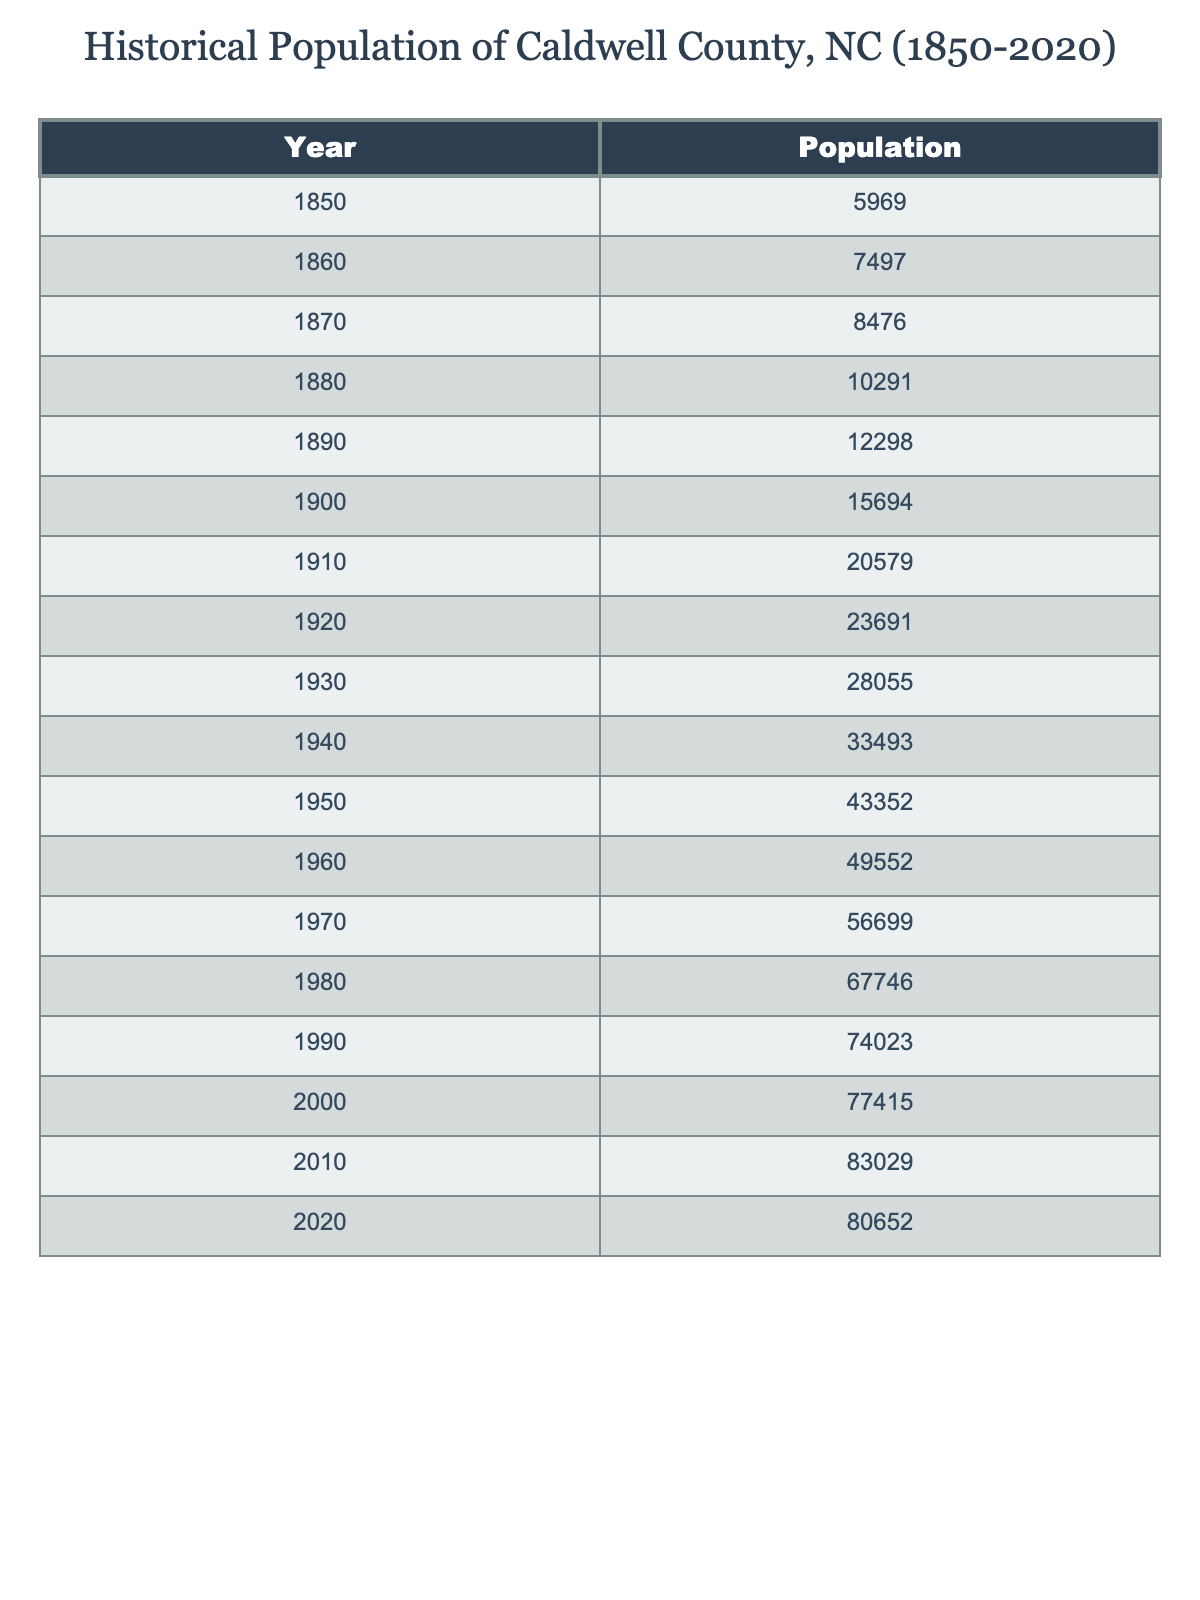What was the population of Caldwell County in 1850? According to the table, the population listed for the year 1850 is 5,969.
Answer: 5,969 What was the population in 1920? The table shows that the population in the year 1920 was 23,691.
Answer: 23,691 What is the population increase from 1900 to 2010? The population in 1900 was 15,694 and in 2010 it was 83,029. The increase is 83,029 - 15,694 = 67,335.
Answer: 67,335 In which decade did Caldwell County experience the highest population growth? By looking at the population differences for each decade, we see the most significant growth occurred from 1940 to 1950 (43,352 - 33,493 = 9,859).
Answer: 1940 to 1950 What was the average population of Caldwell County from 1850 to 2020? To find the average, we sum all the populations and divide by the total number of years (17). The sum is 6,969 + 7,497 + 8,476 + 10,291 + 12,298 + 15,694 + 20,579 + 23,691 + 28,055 + 33,493 + 43,352 + 49,552 + 56,699 + 67,746 + 74,023 + 77,415 + 83,029 + 80,652 = 1,083,530. The average is 1,083,530 / 17 ≈ 63,715.
Answer: 63,715 Did Caldwell County's population decrease from 2010 to 2020? The population in 2010 was 83,029, and in 2020 it was 80,652. Since 80,652 < 83,029, the population did decrease during this period.
Answer: Yes What is the total population of Caldwell County from 1850 to 2020? The total population is the sum of the populations from all the years listed. Adding them gives us 1,083,530.
Answer: 1,083,530 How much did the population grow from 1860 to 1870? The population in 1860 was 7,497 and in 1870 was 8,476. To find the growth, subtract: 8,476 - 7,497 = 979.
Answer: 979 Was there a population decline in the decade from 2000 to 2010? The population for 2000 was 77,415 and for 2010 was 83,029. Since 83,029 > 77,415, there was no decline.
Answer: No In which decade did Caldwell County first exceed a population of 50,000? The population first exceeded 50,000 in the decade of 1960, as the population listed for 1960 is 49,552, but in 1970 it is 56,699.
Answer: 1970s 